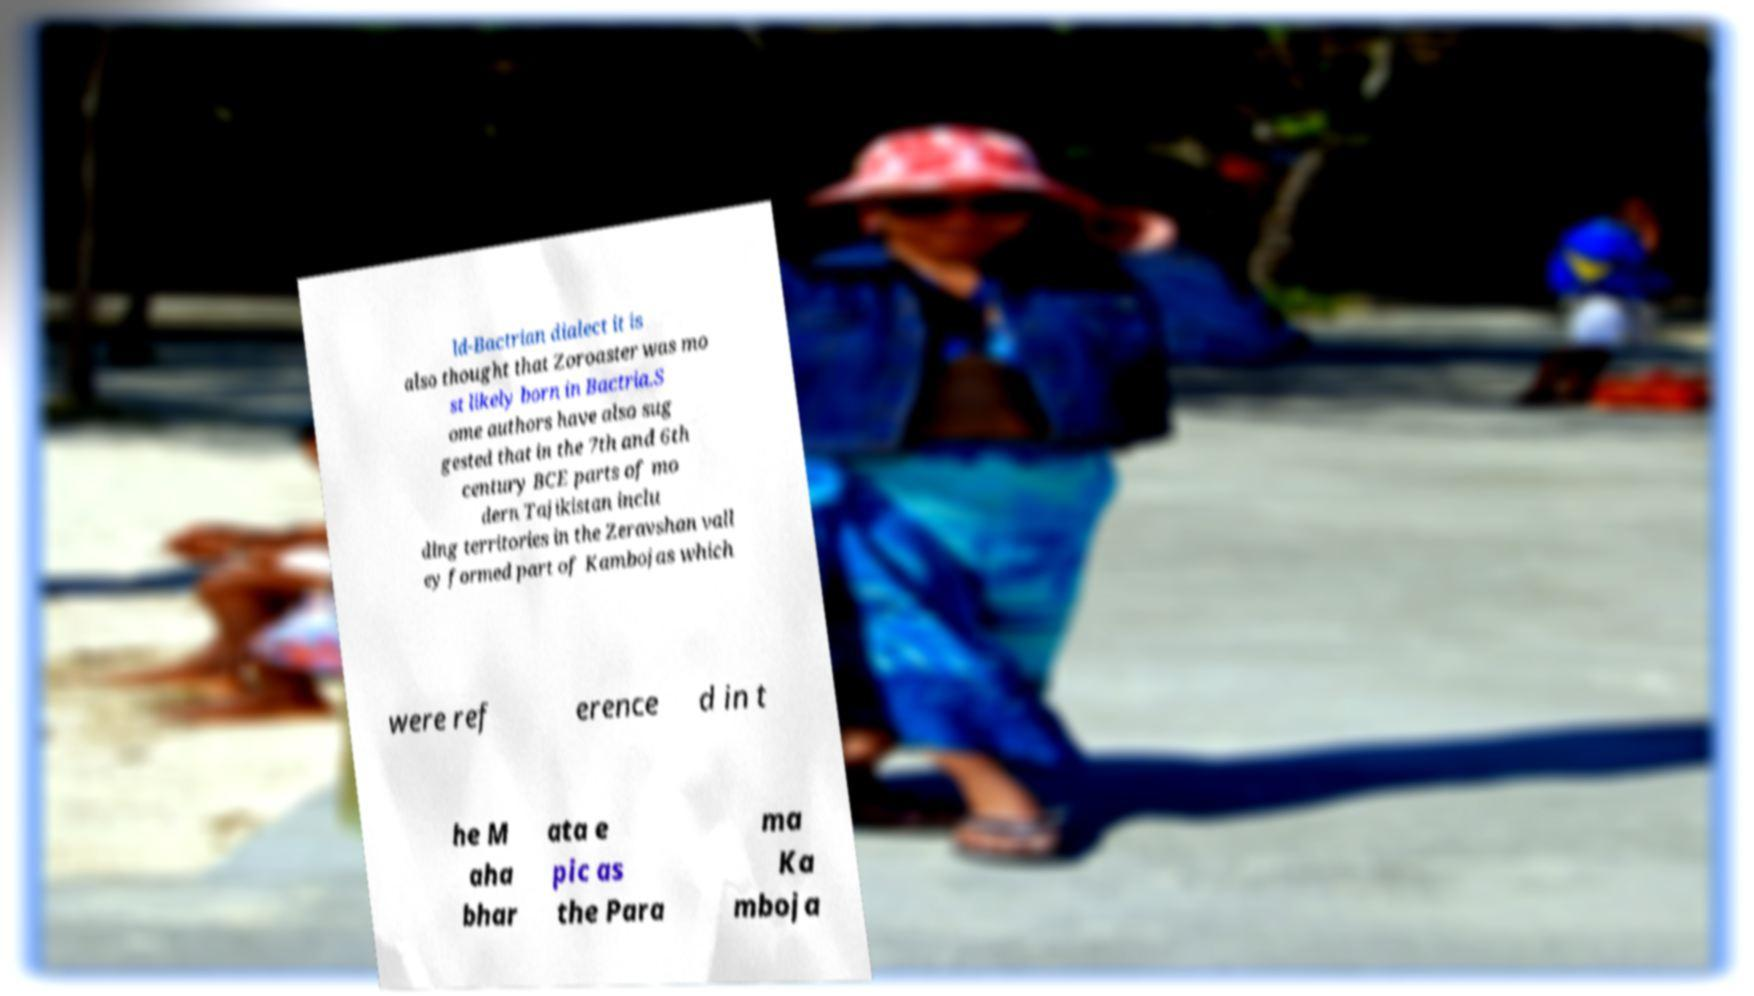For documentation purposes, I need the text within this image transcribed. Could you provide that? ld-Bactrian dialect it is also thought that Zoroaster was mo st likely born in Bactria.S ome authors have also sug gested that in the 7th and 6th century BCE parts of mo dern Tajikistan inclu ding territories in the Zeravshan vall ey formed part of Kambojas which were ref erence d in t he M aha bhar ata e pic as the Para ma Ka mboja 